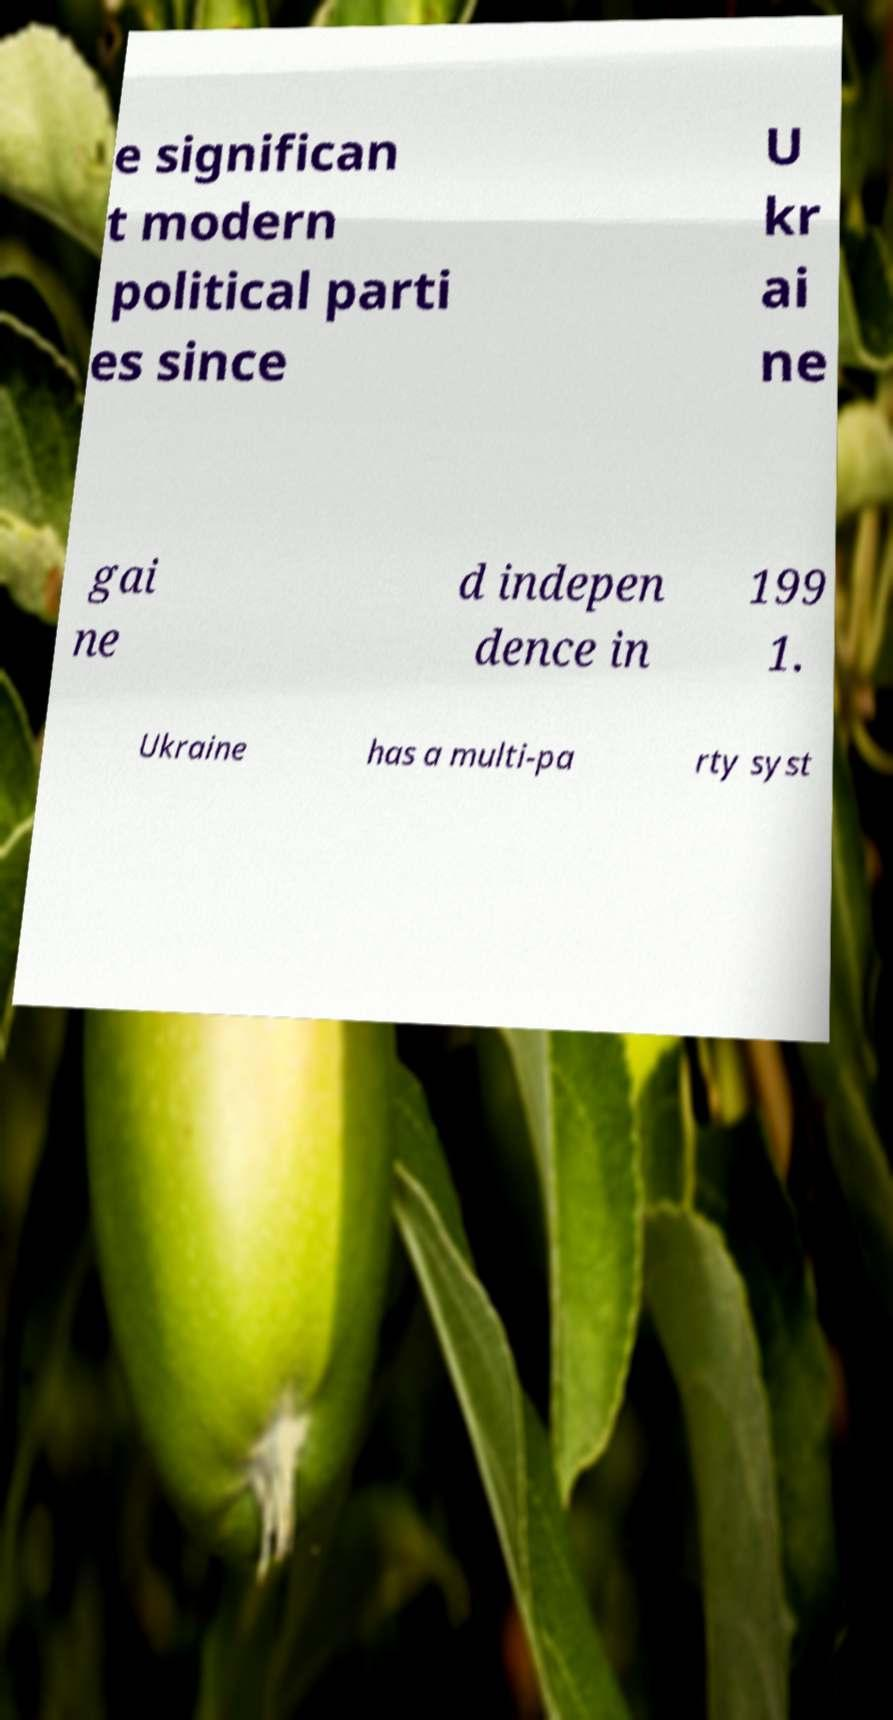What messages or text are displayed in this image? I need them in a readable, typed format. e significan t modern political parti es since U kr ai ne gai ne d indepen dence in 199 1. Ukraine has a multi-pa rty syst 